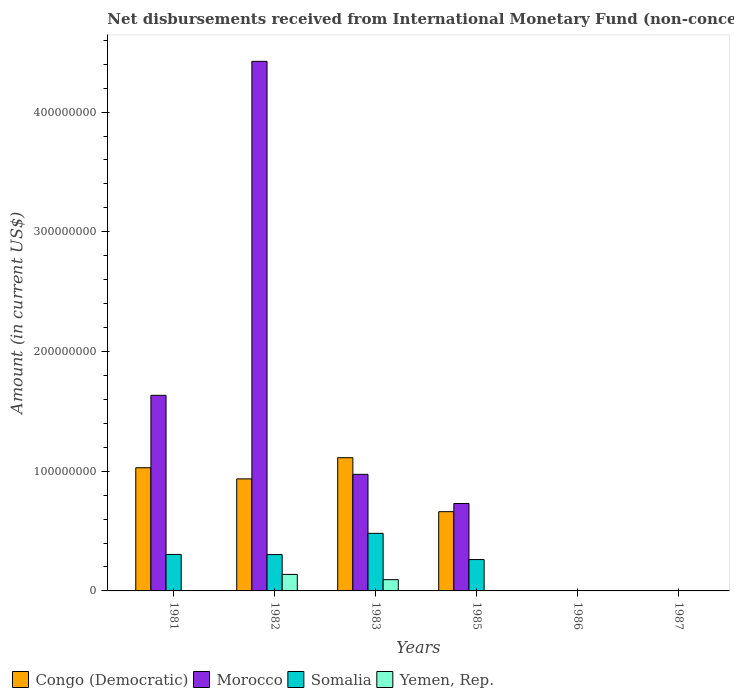How many different coloured bars are there?
Provide a short and direct response. 4. Are the number of bars on each tick of the X-axis equal?
Provide a short and direct response. No. How many bars are there on the 6th tick from the left?
Make the answer very short. 0. What is the label of the 2nd group of bars from the left?
Keep it short and to the point. 1982. What is the amount of disbursements received from International Monetary Fund in Yemen, Rep. in 1982?
Keep it short and to the point. 1.38e+07. Across all years, what is the maximum amount of disbursements received from International Monetary Fund in Yemen, Rep.?
Offer a very short reply. 1.38e+07. In which year was the amount of disbursements received from International Monetary Fund in Morocco maximum?
Offer a very short reply. 1982. What is the total amount of disbursements received from International Monetary Fund in Yemen, Rep. in the graph?
Provide a succinct answer. 2.32e+07. What is the difference between the amount of disbursements received from International Monetary Fund in Congo (Democratic) in 1981 and that in 1983?
Offer a very short reply. -8.40e+06. What is the difference between the amount of disbursements received from International Monetary Fund in Morocco in 1981 and the amount of disbursements received from International Monetary Fund in Congo (Democratic) in 1983?
Make the answer very short. 5.21e+07. What is the average amount of disbursements received from International Monetary Fund in Congo (Democratic) per year?
Ensure brevity in your answer.  6.23e+07. In the year 1983, what is the difference between the amount of disbursements received from International Monetary Fund in Morocco and amount of disbursements received from International Monetary Fund in Yemen, Rep.?
Make the answer very short. 8.80e+07. What is the ratio of the amount of disbursements received from International Monetary Fund in Morocco in 1981 to that in 1983?
Make the answer very short. 1.68. Is the amount of disbursements received from International Monetary Fund in Somalia in 1982 less than that in 1985?
Keep it short and to the point. No. Is the difference between the amount of disbursements received from International Monetary Fund in Morocco in 1982 and 1983 greater than the difference between the amount of disbursements received from International Monetary Fund in Yemen, Rep. in 1982 and 1983?
Your answer should be compact. Yes. What is the difference between the highest and the second highest amount of disbursements received from International Monetary Fund in Congo (Democratic)?
Provide a short and direct response. 8.40e+06. What is the difference between the highest and the lowest amount of disbursements received from International Monetary Fund in Somalia?
Your answer should be compact. 4.81e+07. In how many years, is the amount of disbursements received from International Monetary Fund in Yemen, Rep. greater than the average amount of disbursements received from International Monetary Fund in Yemen, Rep. taken over all years?
Provide a short and direct response. 2. Is it the case that in every year, the sum of the amount of disbursements received from International Monetary Fund in Morocco and amount of disbursements received from International Monetary Fund in Somalia is greater than the sum of amount of disbursements received from International Monetary Fund in Congo (Democratic) and amount of disbursements received from International Monetary Fund in Yemen, Rep.?
Your response must be concise. No. Is it the case that in every year, the sum of the amount of disbursements received from International Monetary Fund in Congo (Democratic) and amount of disbursements received from International Monetary Fund in Somalia is greater than the amount of disbursements received from International Monetary Fund in Yemen, Rep.?
Give a very brief answer. No. How many bars are there?
Keep it short and to the point. 14. Are all the bars in the graph horizontal?
Make the answer very short. No. What is the difference between two consecutive major ticks on the Y-axis?
Provide a succinct answer. 1.00e+08. Are the values on the major ticks of Y-axis written in scientific E-notation?
Provide a short and direct response. No. Does the graph contain any zero values?
Keep it short and to the point. Yes. Does the graph contain grids?
Give a very brief answer. No. What is the title of the graph?
Your response must be concise. Net disbursements received from International Monetary Fund (non-concessional). What is the label or title of the X-axis?
Make the answer very short. Years. What is the label or title of the Y-axis?
Provide a short and direct response. Amount (in current US$). What is the Amount (in current US$) of Congo (Democratic) in 1981?
Keep it short and to the point. 1.03e+08. What is the Amount (in current US$) in Morocco in 1981?
Provide a short and direct response. 1.63e+08. What is the Amount (in current US$) in Somalia in 1981?
Provide a short and direct response. 3.05e+07. What is the Amount (in current US$) of Yemen, Rep. in 1981?
Your answer should be very brief. 0. What is the Amount (in current US$) in Congo (Democratic) in 1982?
Offer a terse response. 9.36e+07. What is the Amount (in current US$) of Morocco in 1982?
Your response must be concise. 4.42e+08. What is the Amount (in current US$) in Somalia in 1982?
Provide a succinct answer. 3.04e+07. What is the Amount (in current US$) in Yemen, Rep. in 1982?
Your response must be concise. 1.38e+07. What is the Amount (in current US$) of Congo (Democratic) in 1983?
Ensure brevity in your answer.  1.11e+08. What is the Amount (in current US$) in Morocco in 1983?
Offer a terse response. 9.74e+07. What is the Amount (in current US$) in Somalia in 1983?
Keep it short and to the point. 4.81e+07. What is the Amount (in current US$) in Yemen, Rep. in 1983?
Provide a short and direct response. 9.40e+06. What is the Amount (in current US$) of Congo (Democratic) in 1985?
Your answer should be very brief. 6.62e+07. What is the Amount (in current US$) of Morocco in 1985?
Offer a terse response. 7.30e+07. What is the Amount (in current US$) in Somalia in 1985?
Offer a terse response. 2.62e+07. What is the Amount (in current US$) in Congo (Democratic) in 1986?
Your answer should be very brief. 0. What is the Amount (in current US$) of Morocco in 1986?
Provide a short and direct response. 0. What is the Amount (in current US$) of Congo (Democratic) in 1987?
Your response must be concise. 0. What is the Amount (in current US$) in Morocco in 1987?
Your answer should be compact. 0. What is the Amount (in current US$) in Somalia in 1987?
Your answer should be compact. 0. What is the Amount (in current US$) of Yemen, Rep. in 1987?
Your response must be concise. 0. Across all years, what is the maximum Amount (in current US$) in Congo (Democratic)?
Your answer should be very brief. 1.11e+08. Across all years, what is the maximum Amount (in current US$) of Morocco?
Offer a terse response. 4.42e+08. Across all years, what is the maximum Amount (in current US$) of Somalia?
Your answer should be very brief. 4.81e+07. Across all years, what is the maximum Amount (in current US$) of Yemen, Rep.?
Keep it short and to the point. 1.38e+07. Across all years, what is the minimum Amount (in current US$) of Congo (Democratic)?
Give a very brief answer. 0. Across all years, what is the minimum Amount (in current US$) in Morocco?
Your response must be concise. 0. Across all years, what is the minimum Amount (in current US$) of Yemen, Rep.?
Your answer should be compact. 0. What is the total Amount (in current US$) of Congo (Democratic) in the graph?
Provide a short and direct response. 3.74e+08. What is the total Amount (in current US$) in Morocco in the graph?
Ensure brevity in your answer.  7.76e+08. What is the total Amount (in current US$) in Somalia in the graph?
Provide a short and direct response. 1.35e+08. What is the total Amount (in current US$) in Yemen, Rep. in the graph?
Offer a terse response. 2.32e+07. What is the difference between the Amount (in current US$) of Congo (Democratic) in 1981 and that in 1982?
Provide a succinct answer. 9.30e+06. What is the difference between the Amount (in current US$) in Morocco in 1981 and that in 1982?
Keep it short and to the point. -2.79e+08. What is the difference between the Amount (in current US$) in Congo (Democratic) in 1981 and that in 1983?
Your answer should be very brief. -8.40e+06. What is the difference between the Amount (in current US$) of Morocco in 1981 and that in 1983?
Keep it short and to the point. 6.60e+07. What is the difference between the Amount (in current US$) of Somalia in 1981 and that in 1983?
Provide a succinct answer. -1.76e+07. What is the difference between the Amount (in current US$) of Congo (Democratic) in 1981 and that in 1985?
Offer a terse response. 3.67e+07. What is the difference between the Amount (in current US$) of Morocco in 1981 and that in 1985?
Your answer should be compact. 9.04e+07. What is the difference between the Amount (in current US$) in Somalia in 1981 and that in 1985?
Your answer should be very brief. 4.28e+06. What is the difference between the Amount (in current US$) in Congo (Democratic) in 1982 and that in 1983?
Provide a short and direct response. -1.77e+07. What is the difference between the Amount (in current US$) of Morocco in 1982 and that in 1983?
Your response must be concise. 3.45e+08. What is the difference between the Amount (in current US$) in Somalia in 1982 and that in 1983?
Your answer should be compact. -1.77e+07. What is the difference between the Amount (in current US$) of Yemen, Rep. in 1982 and that in 1983?
Offer a very short reply. 4.40e+06. What is the difference between the Amount (in current US$) in Congo (Democratic) in 1982 and that in 1985?
Your answer should be very brief. 2.74e+07. What is the difference between the Amount (in current US$) of Morocco in 1982 and that in 1985?
Your answer should be very brief. 3.69e+08. What is the difference between the Amount (in current US$) of Somalia in 1982 and that in 1985?
Ensure brevity in your answer.  4.16e+06. What is the difference between the Amount (in current US$) of Congo (Democratic) in 1983 and that in 1985?
Make the answer very short. 4.51e+07. What is the difference between the Amount (in current US$) in Morocco in 1983 and that in 1985?
Provide a short and direct response. 2.44e+07. What is the difference between the Amount (in current US$) in Somalia in 1983 and that in 1985?
Your response must be concise. 2.19e+07. What is the difference between the Amount (in current US$) in Congo (Democratic) in 1981 and the Amount (in current US$) in Morocco in 1982?
Keep it short and to the point. -3.40e+08. What is the difference between the Amount (in current US$) of Congo (Democratic) in 1981 and the Amount (in current US$) of Somalia in 1982?
Your answer should be very brief. 7.25e+07. What is the difference between the Amount (in current US$) of Congo (Democratic) in 1981 and the Amount (in current US$) of Yemen, Rep. in 1982?
Give a very brief answer. 8.91e+07. What is the difference between the Amount (in current US$) in Morocco in 1981 and the Amount (in current US$) in Somalia in 1982?
Your answer should be very brief. 1.33e+08. What is the difference between the Amount (in current US$) of Morocco in 1981 and the Amount (in current US$) of Yemen, Rep. in 1982?
Your answer should be very brief. 1.50e+08. What is the difference between the Amount (in current US$) of Somalia in 1981 and the Amount (in current US$) of Yemen, Rep. in 1982?
Your answer should be very brief. 1.67e+07. What is the difference between the Amount (in current US$) of Congo (Democratic) in 1981 and the Amount (in current US$) of Morocco in 1983?
Ensure brevity in your answer.  5.50e+06. What is the difference between the Amount (in current US$) of Congo (Democratic) in 1981 and the Amount (in current US$) of Somalia in 1983?
Provide a short and direct response. 5.48e+07. What is the difference between the Amount (in current US$) of Congo (Democratic) in 1981 and the Amount (in current US$) of Yemen, Rep. in 1983?
Offer a terse response. 9.35e+07. What is the difference between the Amount (in current US$) of Morocco in 1981 and the Amount (in current US$) of Somalia in 1983?
Make the answer very short. 1.15e+08. What is the difference between the Amount (in current US$) of Morocco in 1981 and the Amount (in current US$) of Yemen, Rep. in 1983?
Your answer should be very brief. 1.54e+08. What is the difference between the Amount (in current US$) in Somalia in 1981 and the Amount (in current US$) in Yemen, Rep. in 1983?
Provide a short and direct response. 2.11e+07. What is the difference between the Amount (in current US$) of Congo (Democratic) in 1981 and the Amount (in current US$) of Morocco in 1985?
Provide a succinct answer. 2.99e+07. What is the difference between the Amount (in current US$) of Congo (Democratic) in 1981 and the Amount (in current US$) of Somalia in 1985?
Offer a terse response. 7.67e+07. What is the difference between the Amount (in current US$) in Morocco in 1981 and the Amount (in current US$) in Somalia in 1985?
Make the answer very short. 1.37e+08. What is the difference between the Amount (in current US$) of Congo (Democratic) in 1982 and the Amount (in current US$) of Morocco in 1983?
Your response must be concise. -3.80e+06. What is the difference between the Amount (in current US$) of Congo (Democratic) in 1982 and the Amount (in current US$) of Somalia in 1983?
Your answer should be very brief. 4.55e+07. What is the difference between the Amount (in current US$) in Congo (Democratic) in 1982 and the Amount (in current US$) in Yemen, Rep. in 1983?
Ensure brevity in your answer.  8.42e+07. What is the difference between the Amount (in current US$) in Morocco in 1982 and the Amount (in current US$) in Somalia in 1983?
Offer a terse response. 3.94e+08. What is the difference between the Amount (in current US$) in Morocco in 1982 and the Amount (in current US$) in Yemen, Rep. in 1983?
Ensure brevity in your answer.  4.33e+08. What is the difference between the Amount (in current US$) of Somalia in 1982 and the Amount (in current US$) of Yemen, Rep. in 1983?
Your answer should be very brief. 2.10e+07. What is the difference between the Amount (in current US$) in Congo (Democratic) in 1982 and the Amount (in current US$) in Morocco in 1985?
Your answer should be compact. 2.06e+07. What is the difference between the Amount (in current US$) in Congo (Democratic) in 1982 and the Amount (in current US$) in Somalia in 1985?
Provide a short and direct response. 6.74e+07. What is the difference between the Amount (in current US$) in Morocco in 1982 and the Amount (in current US$) in Somalia in 1985?
Keep it short and to the point. 4.16e+08. What is the difference between the Amount (in current US$) in Congo (Democratic) in 1983 and the Amount (in current US$) in Morocco in 1985?
Provide a short and direct response. 3.83e+07. What is the difference between the Amount (in current US$) of Congo (Democratic) in 1983 and the Amount (in current US$) of Somalia in 1985?
Your answer should be compact. 8.51e+07. What is the difference between the Amount (in current US$) in Morocco in 1983 and the Amount (in current US$) in Somalia in 1985?
Offer a terse response. 7.12e+07. What is the average Amount (in current US$) of Congo (Democratic) per year?
Provide a succinct answer. 6.23e+07. What is the average Amount (in current US$) of Morocco per year?
Provide a succinct answer. 1.29e+08. What is the average Amount (in current US$) in Somalia per year?
Give a very brief answer. 2.25e+07. What is the average Amount (in current US$) of Yemen, Rep. per year?
Make the answer very short. 3.87e+06. In the year 1981, what is the difference between the Amount (in current US$) in Congo (Democratic) and Amount (in current US$) in Morocco?
Offer a terse response. -6.05e+07. In the year 1981, what is the difference between the Amount (in current US$) of Congo (Democratic) and Amount (in current US$) of Somalia?
Ensure brevity in your answer.  7.24e+07. In the year 1981, what is the difference between the Amount (in current US$) in Morocco and Amount (in current US$) in Somalia?
Ensure brevity in your answer.  1.33e+08. In the year 1982, what is the difference between the Amount (in current US$) of Congo (Democratic) and Amount (in current US$) of Morocco?
Your response must be concise. -3.49e+08. In the year 1982, what is the difference between the Amount (in current US$) of Congo (Democratic) and Amount (in current US$) of Somalia?
Ensure brevity in your answer.  6.32e+07. In the year 1982, what is the difference between the Amount (in current US$) of Congo (Democratic) and Amount (in current US$) of Yemen, Rep.?
Offer a very short reply. 7.98e+07. In the year 1982, what is the difference between the Amount (in current US$) of Morocco and Amount (in current US$) of Somalia?
Ensure brevity in your answer.  4.12e+08. In the year 1982, what is the difference between the Amount (in current US$) of Morocco and Amount (in current US$) of Yemen, Rep.?
Your answer should be very brief. 4.29e+08. In the year 1982, what is the difference between the Amount (in current US$) in Somalia and Amount (in current US$) in Yemen, Rep.?
Keep it short and to the point. 1.66e+07. In the year 1983, what is the difference between the Amount (in current US$) of Congo (Democratic) and Amount (in current US$) of Morocco?
Ensure brevity in your answer.  1.39e+07. In the year 1983, what is the difference between the Amount (in current US$) in Congo (Democratic) and Amount (in current US$) in Somalia?
Your response must be concise. 6.32e+07. In the year 1983, what is the difference between the Amount (in current US$) in Congo (Democratic) and Amount (in current US$) in Yemen, Rep.?
Your answer should be very brief. 1.02e+08. In the year 1983, what is the difference between the Amount (in current US$) in Morocco and Amount (in current US$) in Somalia?
Your answer should be very brief. 4.93e+07. In the year 1983, what is the difference between the Amount (in current US$) of Morocco and Amount (in current US$) of Yemen, Rep.?
Your response must be concise. 8.80e+07. In the year 1983, what is the difference between the Amount (in current US$) in Somalia and Amount (in current US$) in Yemen, Rep.?
Your answer should be compact. 3.87e+07. In the year 1985, what is the difference between the Amount (in current US$) of Congo (Democratic) and Amount (in current US$) of Morocco?
Provide a succinct answer. -6.84e+06. In the year 1985, what is the difference between the Amount (in current US$) of Congo (Democratic) and Amount (in current US$) of Somalia?
Your response must be concise. 4.00e+07. In the year 1985, what is the difference between the Amount (in current US$) in Morocco and Amount (in current US$) in Somalia?
Your response must be concise. 4.68e+07. What is the ratio of the Amount (in current US$) in Congo (Democratic) in 1981 to that in 1982?
Give a very brief answer. 1.1. What is the ratio of the Amount (in current US$) of Morocco in 1981 to that in 1982?
Make the answer very short. 0.37. What is the ratio of the Amount (in current US$) of Somalia in 1981 to that in 1982?
Offer a very short reply. 1. What is the ratio of the Amount (in current US$) of Congo (Democratic) in 1981 to that in 1983?
Offer a very short reply. 0.92. What is the ratio of the Amount (in current US$) of Morocco in 1981 to that in 1983?
Your answer should be very brief. 1.68. What is the ratio of the Amount (in current US$) in Somalia in 1981 to that in 1983?
Give a very brief answer. 0.63. What is the ratio of the Amount (in current US$) of Congo (Democratic) in 1981 to that in 1985?
Offer a terse response. 1.55. What is the ratio of the Amount (in current US$) of Morocco in 1981 to that in 1985?
Your answer should be very brief. 2.24. What is the ratio of the Amount (in current US$) of Somalia in 1981 to that in 1985?
Ensure brevity in your answer.  1.16. What is the ratio of the Amount (in current US$) of Congo (Democratic) in 1982 to that in 1983?
Ensure brevity in your answer.  0.84. What is the ratio of the Amount (in current US$) in Morocco in 1982 to that in 1983?
Give a very brief answer. 4.54. What is the ratio of the Amount (in current US$) of Somalia in 1982 to that in 1983?
Offer a terse response. 0.63. What is the ratio of the Amount (in current US$) of Yemen, Rep. in 1982 to that in 1983?
Provide a short and direct response. 1.47. What is the ratio of the Amount (in current US$) in Congo (Democratic) in 1982 to that in 1985?
Your answer should be very brief. 1.41. What is the ratio of the Amount (in current US$) of Morocco in 1982 to that in 1985?
Offer a terse response. 6.06. What is the ratio of the Amount (in current US$) of Somalia in 1982 to that in 1985?
Offer a terse response. 1.16. What is the ratio of the Amount (in current US$) of Congo (Democratic) in 1983 to that in 1985?
Offer a terse response. 1.68. What is the ratio of the Amount (in current US$) of Morocco in 1983 to that in 1985?
Provide a succinct answer. 1.33. What is the ratio of the Amount (in current US$) of Somalia in 1983 to that in 1985?
Provide a short and direct response. 1.84. What is the difference between the highest and the second highest Amount (in current US$) of Congo (Democratic)?
Make the answer very short. 8.40e+06. What is the difference between the highest and the second highest Amount (in current US$) of Morocco?
Ensure brevity in your answer.  2.79e+08. What is the difference between the highest and the second highest Amount (in current US$) in Somalia?
Make the answer very short. 1.76e+07. What is the difference between the highest and the lowest Amount (in current US$) of Congo (Democratic)?
Keep it short and to the point. 1.11e+08. What is the difference between the highest and the lowest Amount (in current US$) of Morocco?
Give a very brief answer. 4.42e+08. What is the difference between the highest and the lowest Amount (in current US$) of Somalia?
Provide a short and direct response. 4.81e+07. What is the difference between the highest and the lowest Amount (in current US$) of Yemen, Rep.?
Make the answer very short. 1.38e+07. 